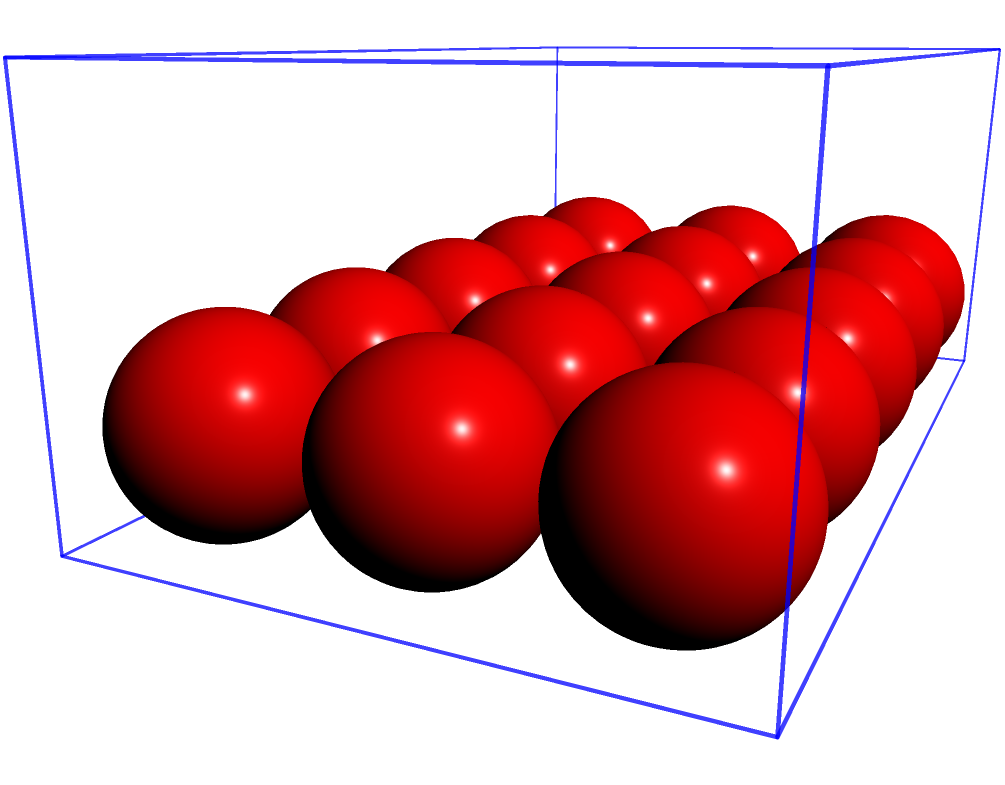As part of your administrative duties, you need to organize stress balls in a desk drawer for the Human Resources department. The rectangular drawer measures 10 inches long, 6 inches wide, and 4 inches deep. Each spherical stress ball has a diameter of 2 inches. How many stress balls can fit in the drawer without stacking them on top of each other? To solve this problem, we need to follow these steps:

1. Determine the number of stress balls that can fit along each dimension of the drawer:
   - Length: $10 \div 2 = 5$ stress balls
   - Width: $6 \div 2 = 3$ stress balls
   - Depth: $4 \div 2 = 2$ stress balls, but we're not stacking, so we'll use 1

2. Calculate the total number of stress balls:
   $$\text{Total} = \text{Length} \times \text{Width} \times \text{Depth}$$
   $$\text{Total} = 5 \times 3 \times 1 = 15$$

Therefore, 15 stress balls can fit in the drawer without stacking them on top of each other.

Note: This calculation assumes perfect packing, which may not be practical in real-world situations. However, for the purpose of this geometric problem, we consider ideal conditions.
Answer: 15 stress balls 